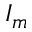<formula> <loc_0><loc_0><loc_500><loc_500>I _ { m }</formula> 